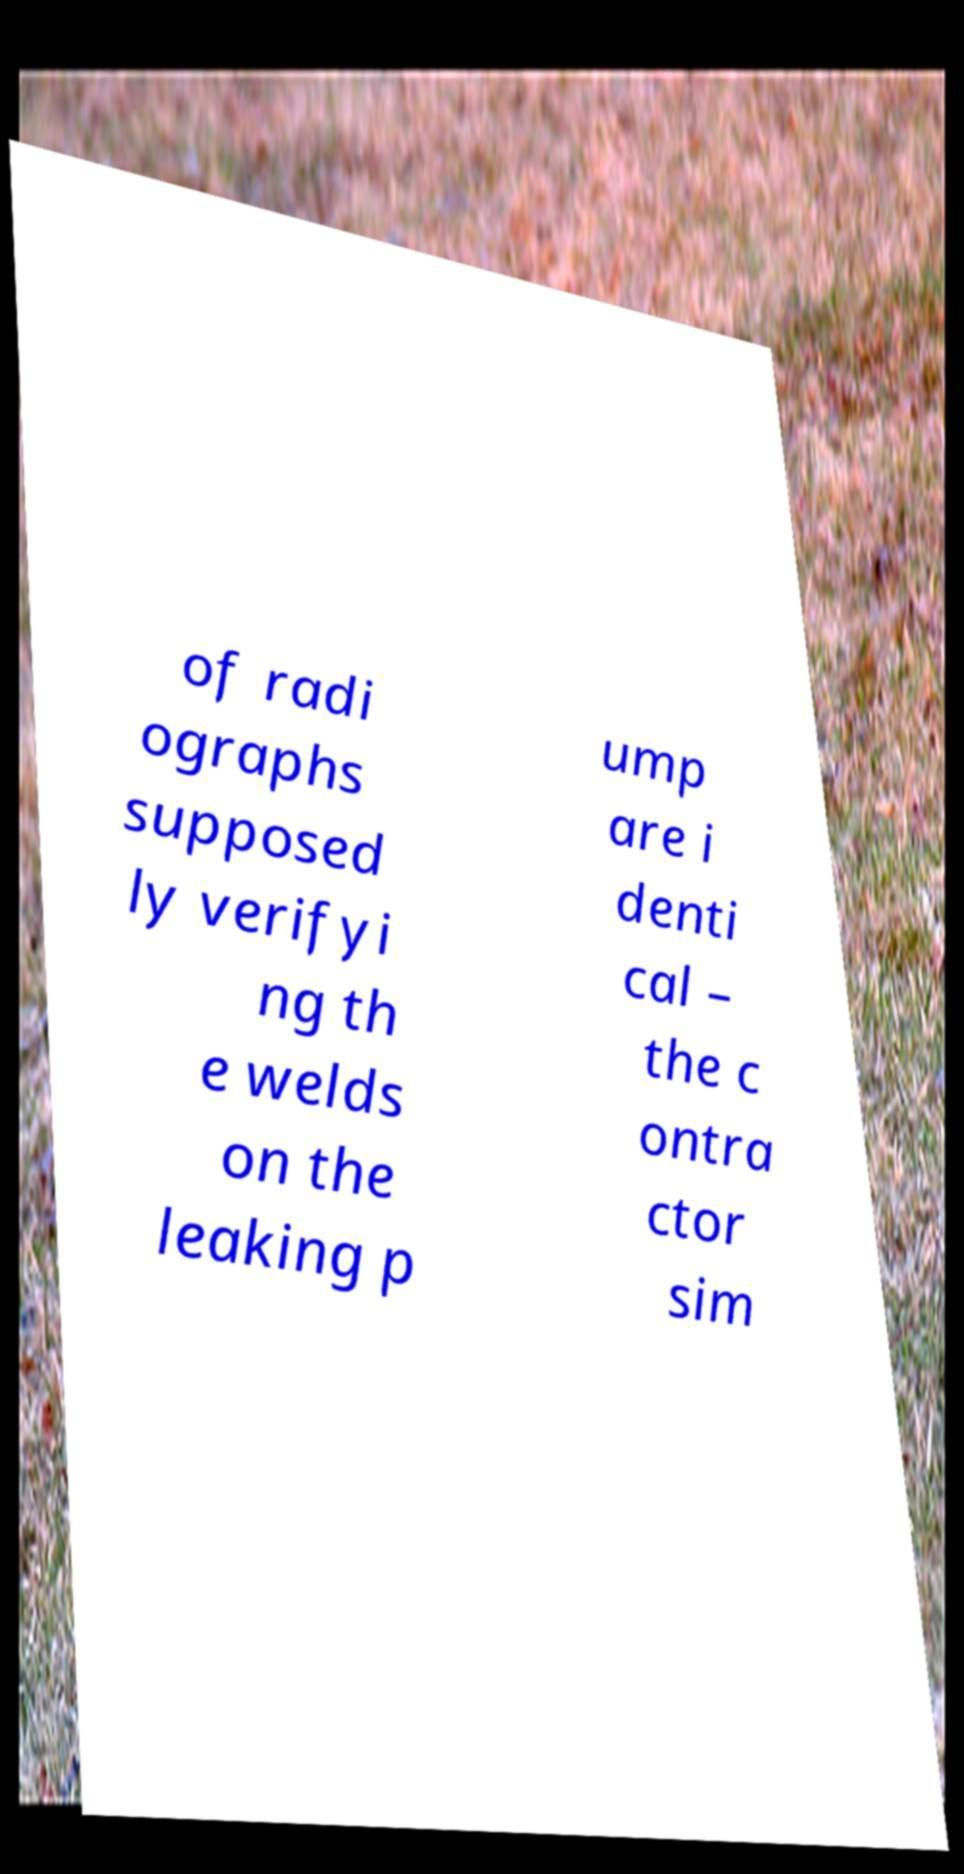Can you accurately transcribe the text from the provided image for me? of radi ographs supposed ly verifyi ng th e welds on the leaking p ump are i denti cal – the c ontra ctor sim 